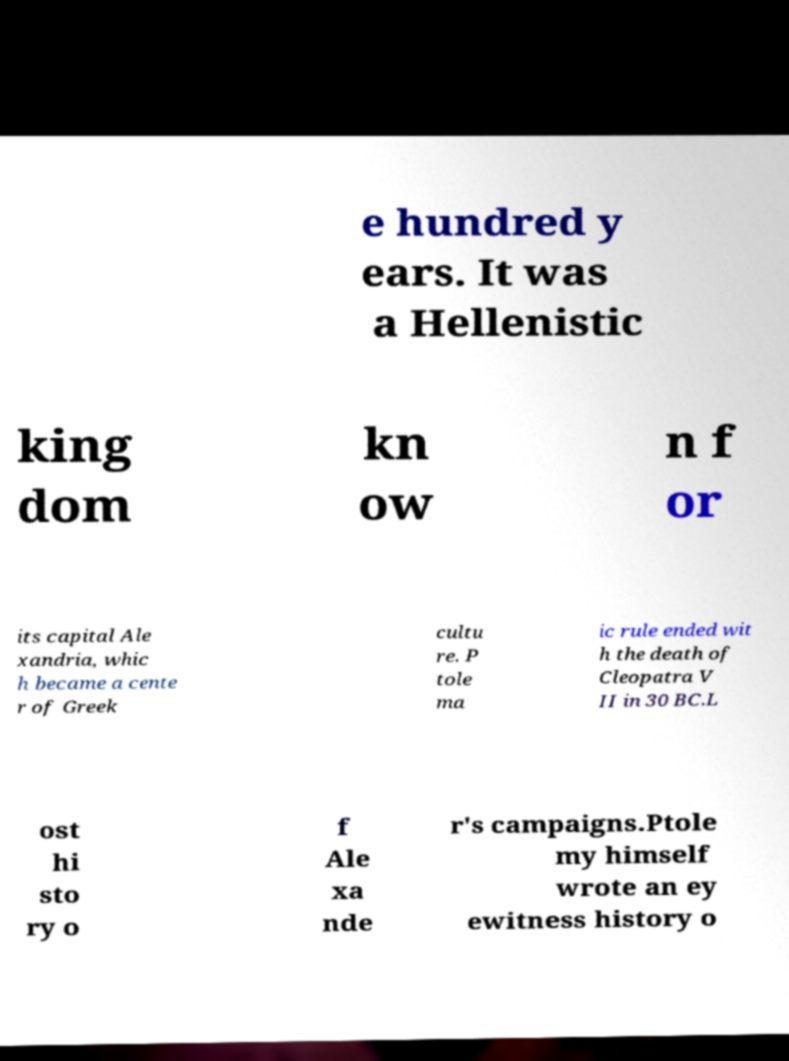Could you assist in decoding the text presented in this image and type it out clearly? e hundred y ears. It was a Hellenistic king dom kn ow n f or its capital Ale xandria, whic h became a cente r of Greek cultu re. P tole ma ic rule ended wit h the death of Cleopatra V II in 30 BC.L ost hi sto ry o f Ale xa nde r's campaigns.Ptole my himself wrote an ey ewitness history o 